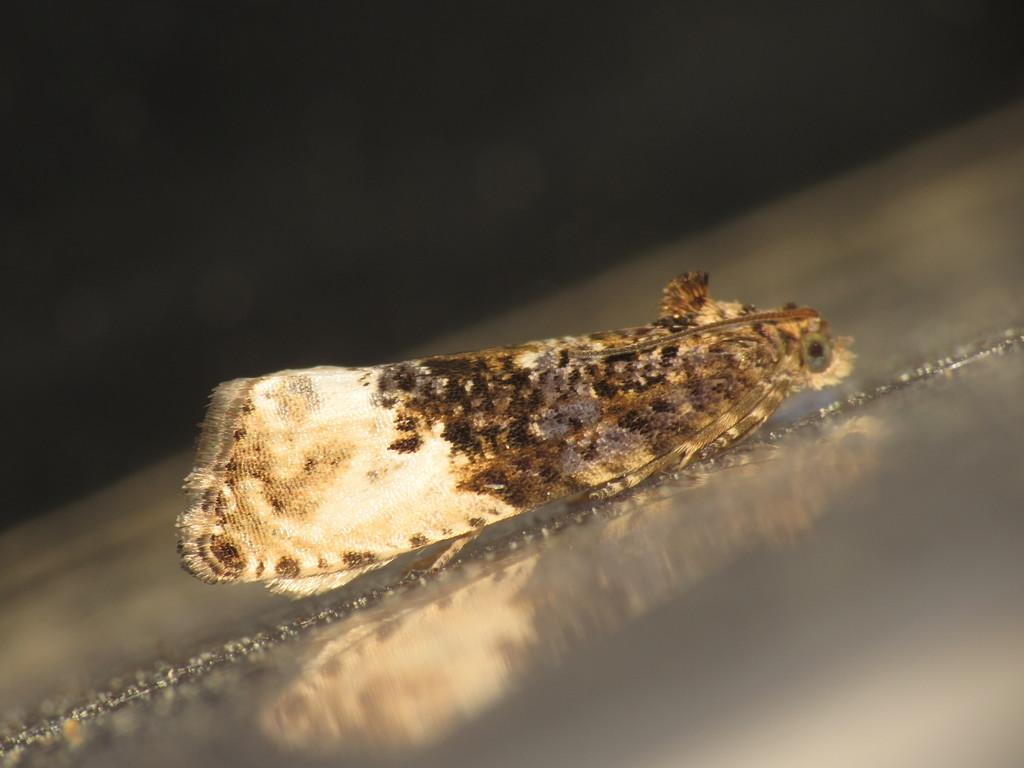What type of creature is present in the image? There is an insect in the image. What physical features does the insect have? The insect has wings and eyes. How does the insect wash its hands in the image? Insects do not have hands, and therefore they cannot wash them. Additionally, there is no indication in the image that the insect is washing anything. 